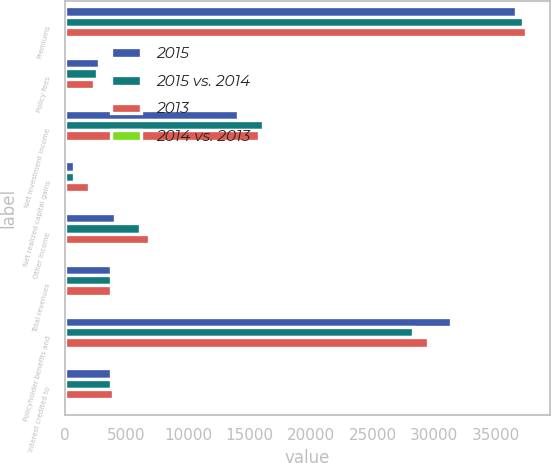Convert chart to OTSL. <chart><loc_0><loc_0><loc_500><loc_500><stacked_bar_chart><ecel><fcel>Premiums<fcel>Policy fees<fcel>Net investment income<fcel>Net realized capital gains<fcel>Other income<fcel>Total revenues<fcel>Policyholder benefits and<fcel>Interest credited to<nl><fcel>2015<fcel>36655<fcel>2755<fcel>14053<fcel>776<fcel>4088<fcel>3731<fcel>31345<fcel>3731<nl><fcel>2015 vs. 2014<fcel>37254<fcel>2615<fcel>16079<fcel>739<fcel>6117<fcel>3731<fcel>28281<fcel>3768<nl><fcel>2013<fcel>37499<fcel>2340<fcel>15810<fcel>1939<fcel>6866<fcel>3731<fcel>29503<fcel>3892<nl><fcel>2014 vs. 2013<fcel>2<fcel>5<fcel>13<fcel>5<fcel>33<fcel>9<fcel>11<fcel>1<nl></chart> 